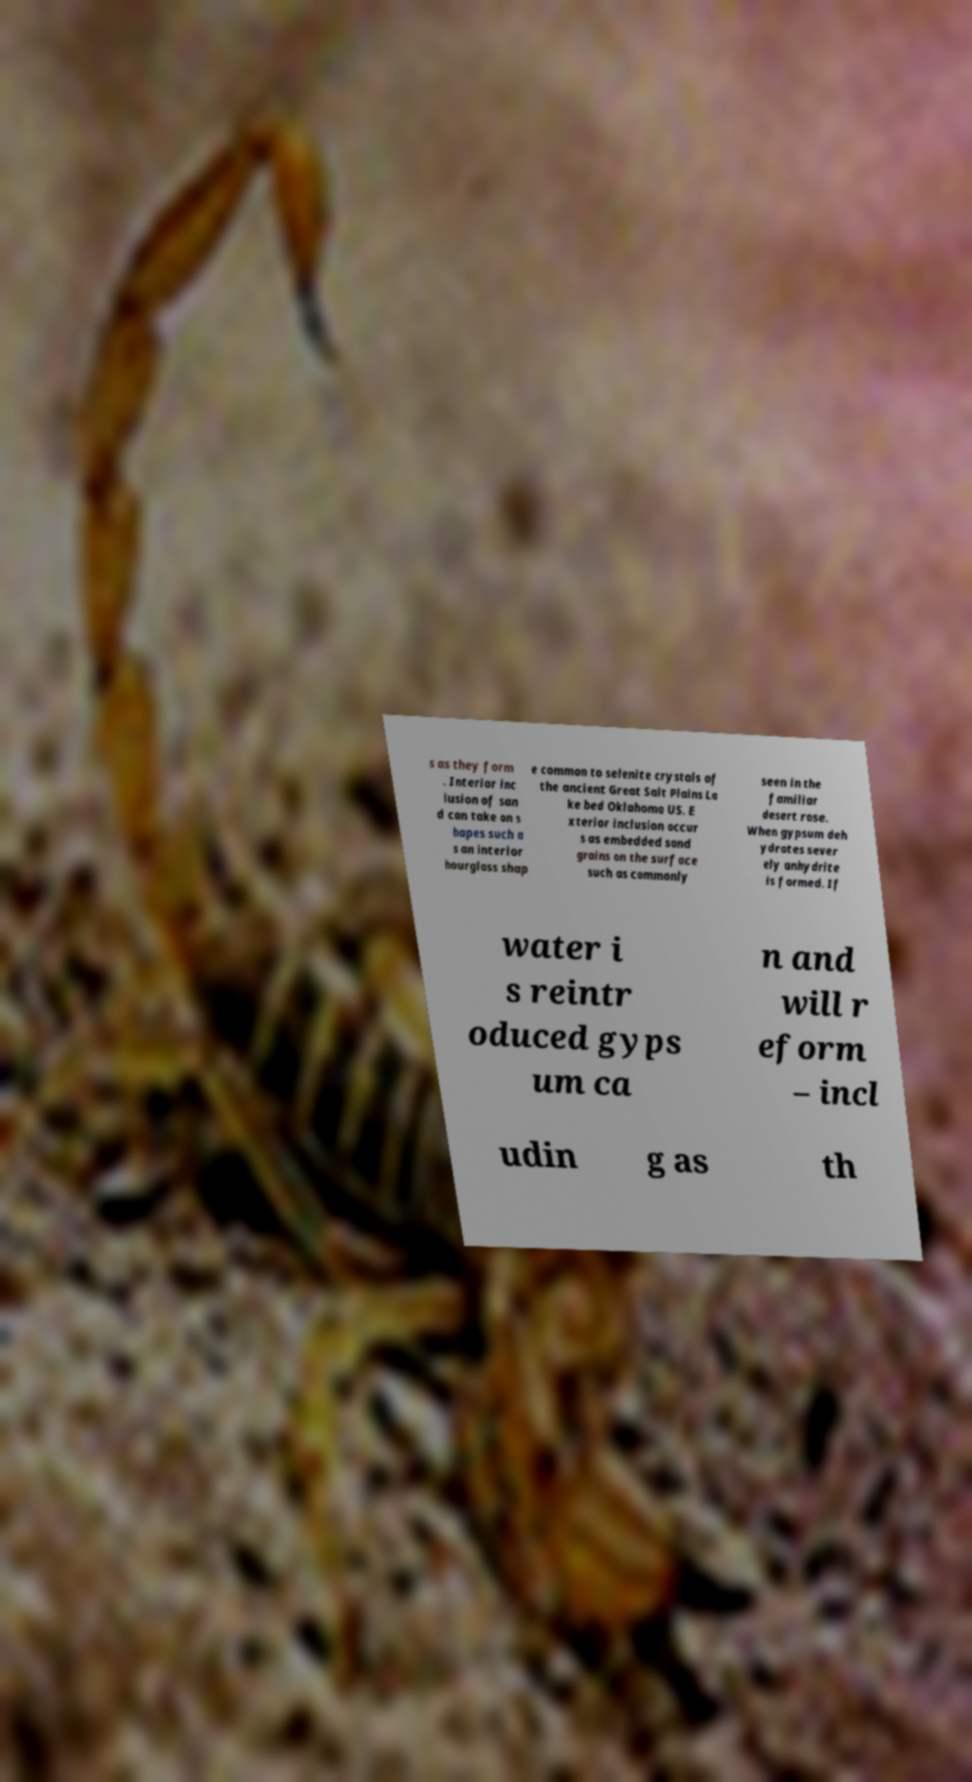Please identify and transcribe the text found in this image. s as they form . Interior inc lusion of san d can take on s hapes such a s an interior hourglass shap e common to selenite crystals of the ancient Great Salt Plains La ke bed Oklahoma US. E xterior inclusion occur s as embedded sand grains on the surface such as commonly seen in the familiar desert rose. When gypsum deh ydrates sever ely anhydrite is formed. If water i s reintr oduced gyps um ca n and will r eform – incl udin g as th 